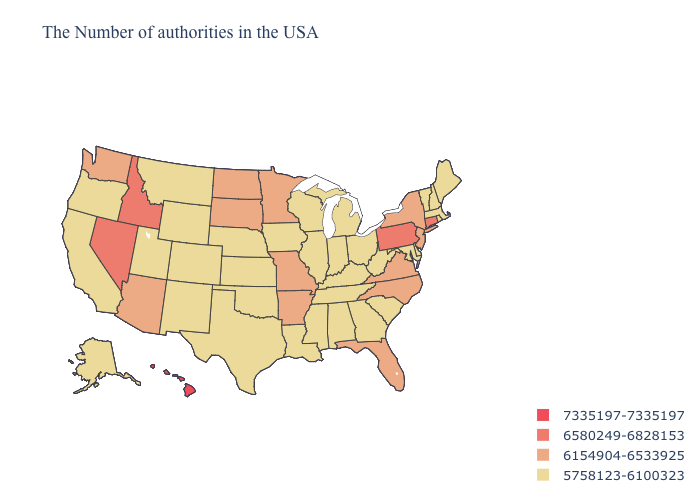Name the states that have a value in the range 5758123-6100323?
Be succinct. Maine, Massachusetts, Rhode Island, New Hampshire, Vermont, Delaware, Maryland, South Carolina, West Virginia, Ohio, Georgia, Michigan, Kentucky, Indiana, Alabama, Tennessee, Wisconsin, Illinois, Mississippi, Louisiana, Iowa, Kansas, Nebraska, Oklahoma, Texas, Wyoming, Colorado, New Mexico, Utah, Montana, California, Oregon, Alaska. What is the highest value in the USA?
Keep it brief. 7335197-7335197. Name the states that have a value in the range 6580249-6828153?
Write a very short answer. Connecticut, Pennsylvania, Idaho, Nevada. Does Kentucky have the same value as Virginia?
Short answer required. No. What is the value of Delaware?
Give a very brief answer. 5758123-6100323. What is the lowest value in the USA?
Be succinct. 5758123-6100323. Which states have the lowest value in the MidWest?
Short answer required. Ohio, Michigan, Indiana, Wisconsin, Illinois, Iowa, Kansas, Nebraska. Does Washington have a higher value than Iowa?
Keep it brief. Yes. What is the lowest value in the USA?
Quick response, please. 5758123-6100323. How many symbols are there in the legend?
Concise answer only. 4. What is the value of West Virginia?
Short answer required. 5758123-6100323. What is the lowest value in the Northeast?
Write a very short answer. 5758123-6100323. How many symbols are there in the legend?
Give a very brief answer. 4. What is the value of Kansas?
Answer briefly. 5758123-6100323. What is the highest value in states that border Oregon?
Be succinct. 6580249-6828153. 